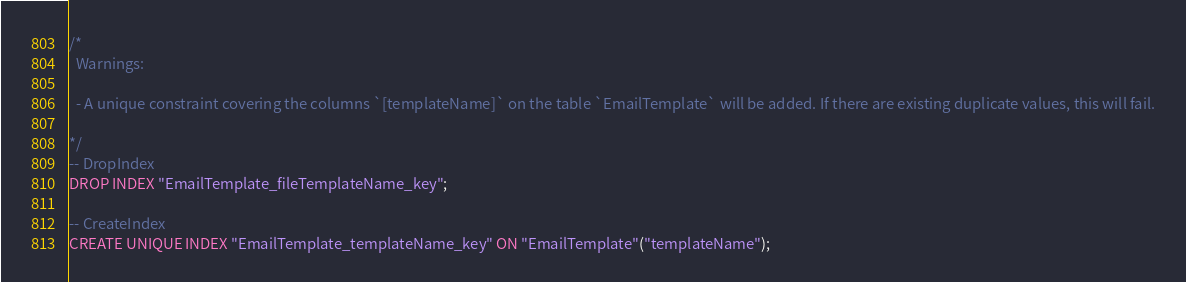<code> <loc_0><loc_0><loc_500><loc_500><_SQL_>/*
  Warnings:

  - A unique constraint covering the columns `[templateName]` on the table `EmailTemplate` will be added. If there are existing duplicate values, this will fail.

*/
-- DropIndex
DROP INDEX "EmailTemplate_fileTemplateName_key";

-- CreateIndex
CREATE UNIQUE INDEX "EmailTemplate_templateName_key" ON "EmailTemplate"("templateName");
</code> 